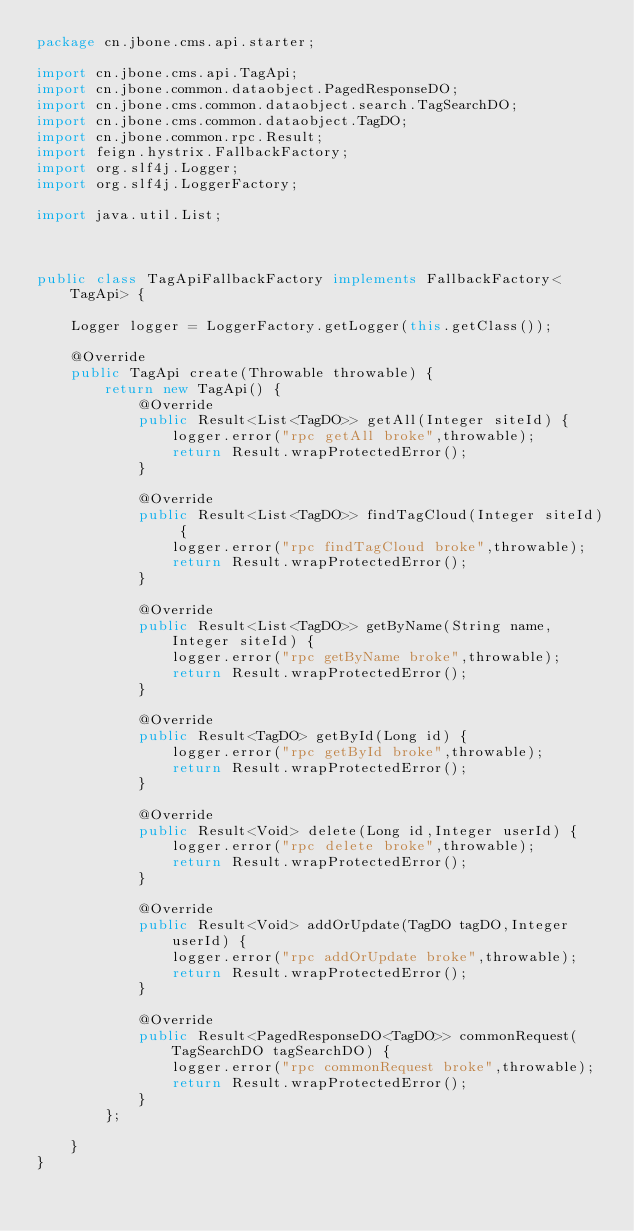Convert code to text. <code><loc_0><loc_0><loc_500><loc_500><_Java_>package cn.jbone.cms.api.starter;

import cn.jbone.cms.api.TagApi;
import cn.jbone.common.dataobject.PagedResponseDO;
import cn.jbone.cms.common.dataobject.search.TagSearchDO;
import cn.jbone.cms.common.dataobject.TagDO;
import cn.jbone.common.rpc.Result;
import feign.hystrix.FallbackFactory;
import org.slf4j.Logger;
import org.slf4j.LoggerFactory;

import java.util.List;



public class TagApiFallbackFactory implements FallbackFactory<TagApi> {

    Logger logger = LoggerFactory.getLogger(this.getClass());

    @Override
    public TagApi create(Throwable throwable) {
        return new TagApi() {
            @Override
            public Result<List<TagDO>> getAll(Integer siteId) {
                logger.error("rpc getAll broke",throwable);
                return Result.wrapProtectedError();
            }

            @Override
            public Result<List<TagDO>> findTagCloud(Integer siteId) {
                logger.error("rpc findTagCloud broke",throwable);
                return Result.wrapProtectedError();
            }

            @Override
            public Result<List<TagDO>> getByName(String name,Integer siteId) {
                logger.error("rpc getByName broke",throwable);
                return Result.wrapProtectedError();
            }

            @Override
            public Result<TagDO> getById(Long id) {
                logger.error("rpc getById broke",throwable);
                return Result.wrapProtectedError();
            }

            @Override
            public Result<Void> delete(Long id,Integer userId) {
                logger.error("rpc delete broke",throwable);
                return Result.wrapProtectedError();
            }

            @Override
            public Result<Void> addOrUpdate(TagDO tagDO,Integer userId) {
                logger.error("rpc addOrUpdate broke",throwable);
                return Result.wrapProtectedError();
            }

            @Override
            public Result<PagedResponseDO<TagDO>> commonRequest(TagSearchDO tagSearchDO) {
                logger.error("rpc commonRequest broke",throwable);
                return Result.wrapProtectedError();
            }
        };

    }
}
</code> 